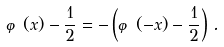Convert formula to latex. <formula><loc_0><loc_0><loc_500><loc_500>\varphi ( x ) - \frac { 1 } { 2 } = - \left ( \varphi ( - x ) - \frac { 1 } { 2 } \right ) \, .</formula> 